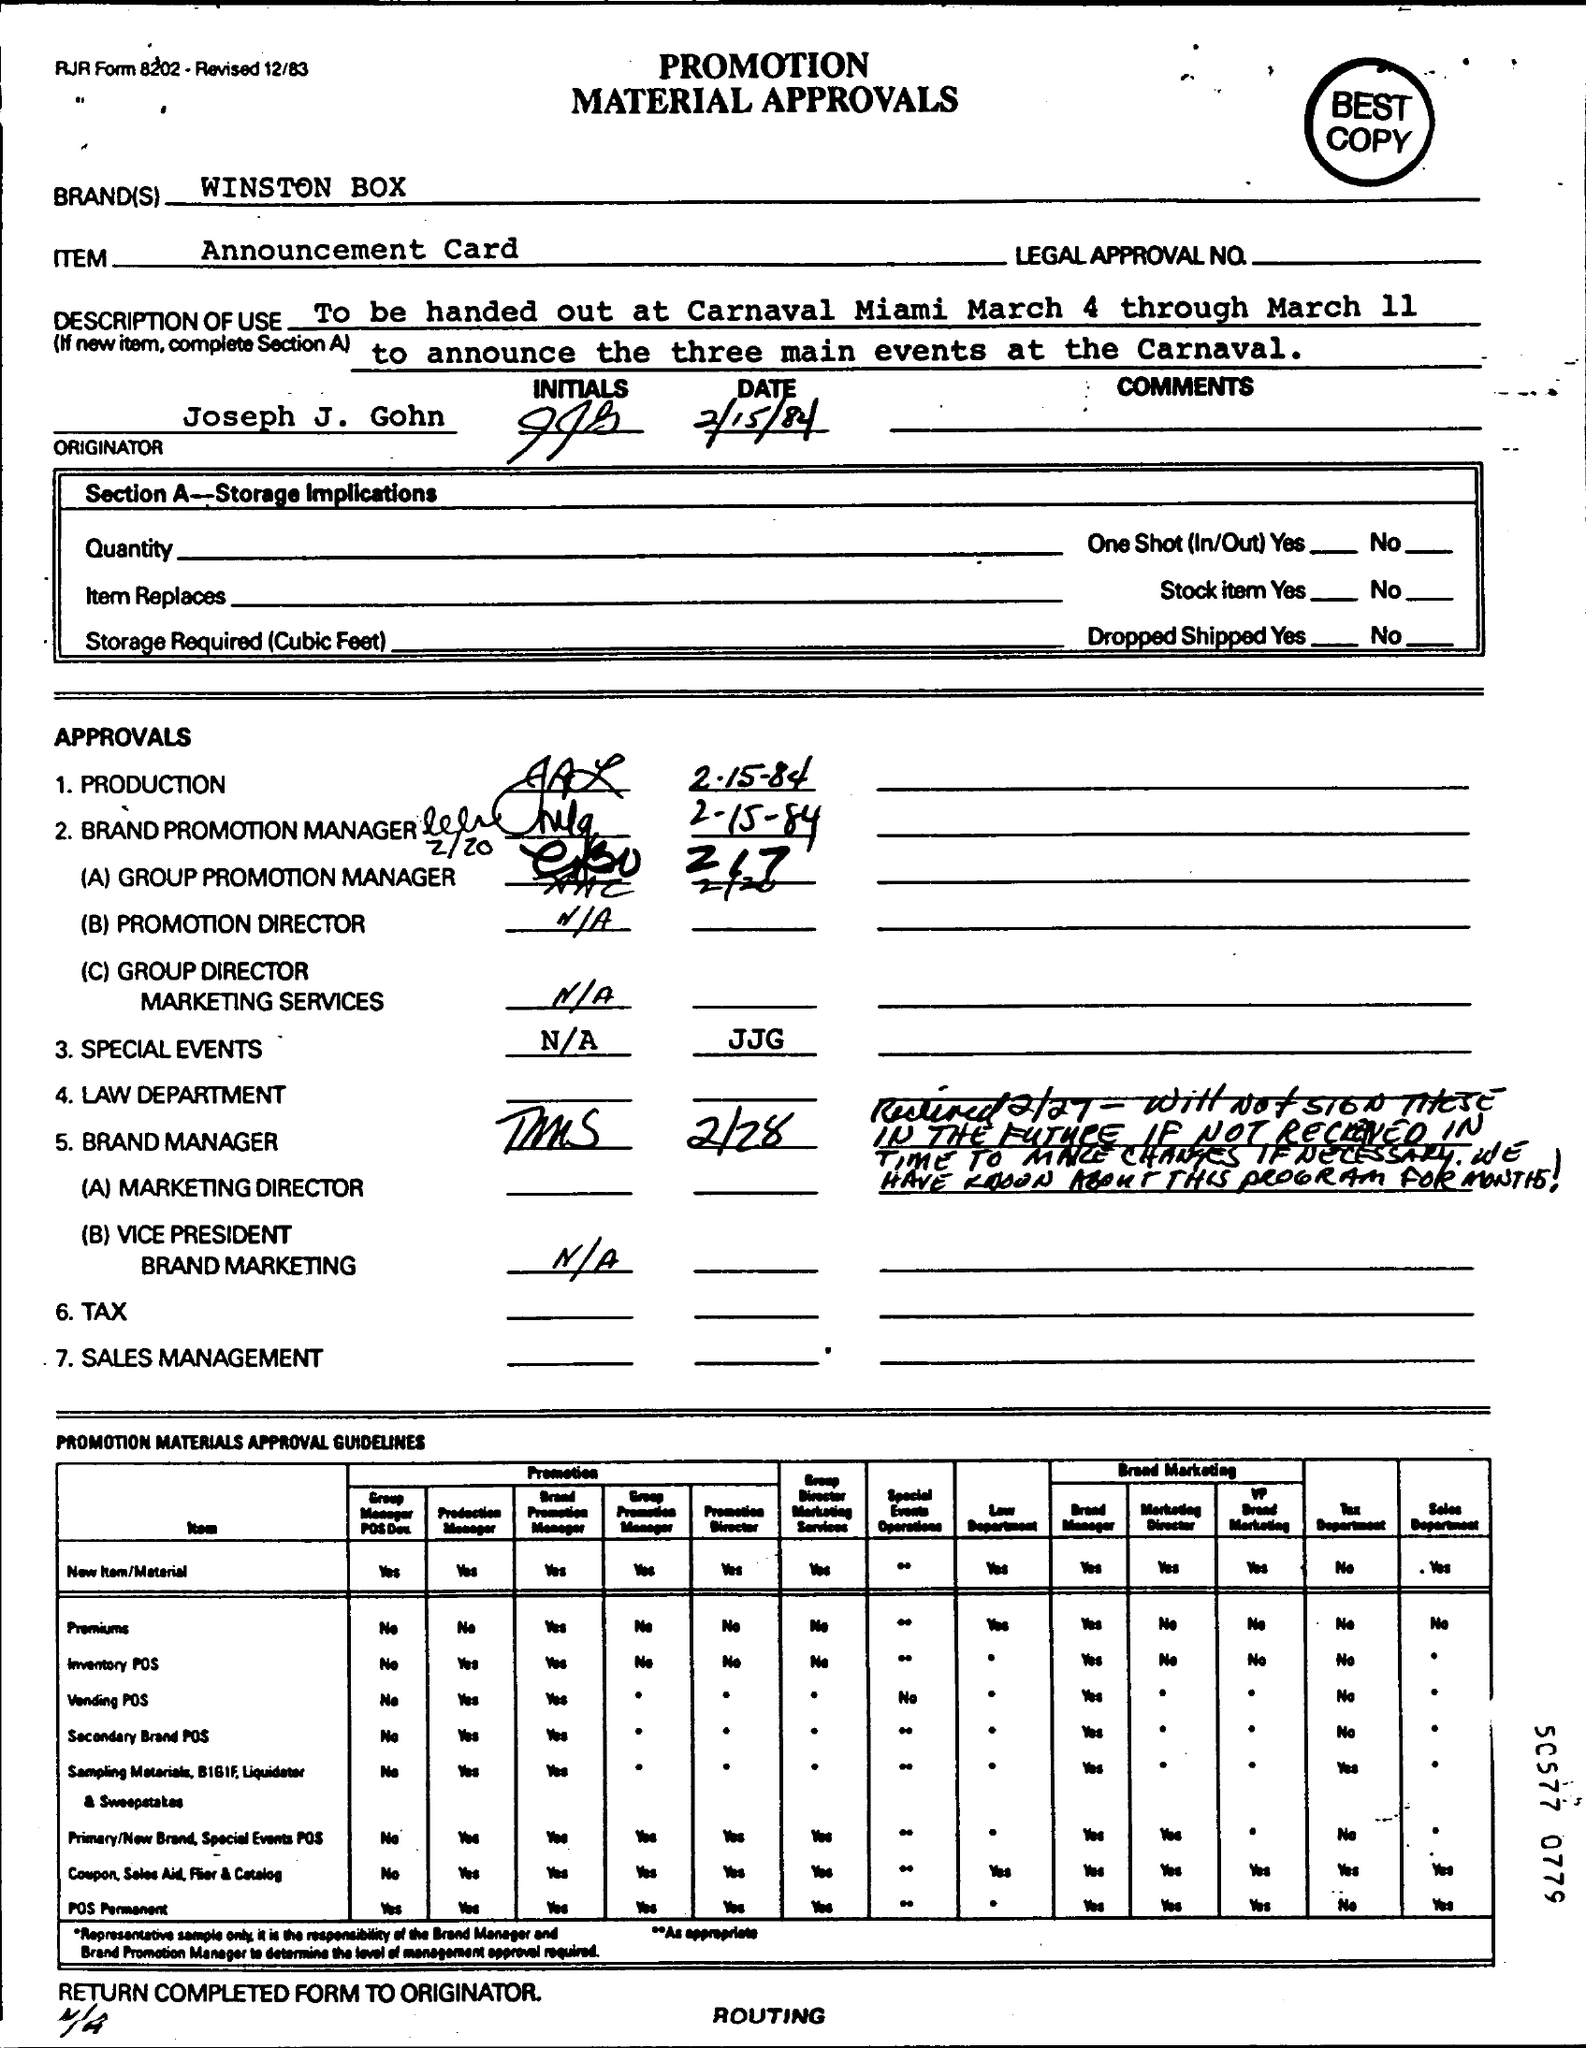Which brand is mentioned?
Offer a very short reply. WINSTON BOX. Who is the originator?
Give a very brief answer. Joseph j. gohn. What is the item mentioned?
Provide a succinct answer. Announcement Card. 